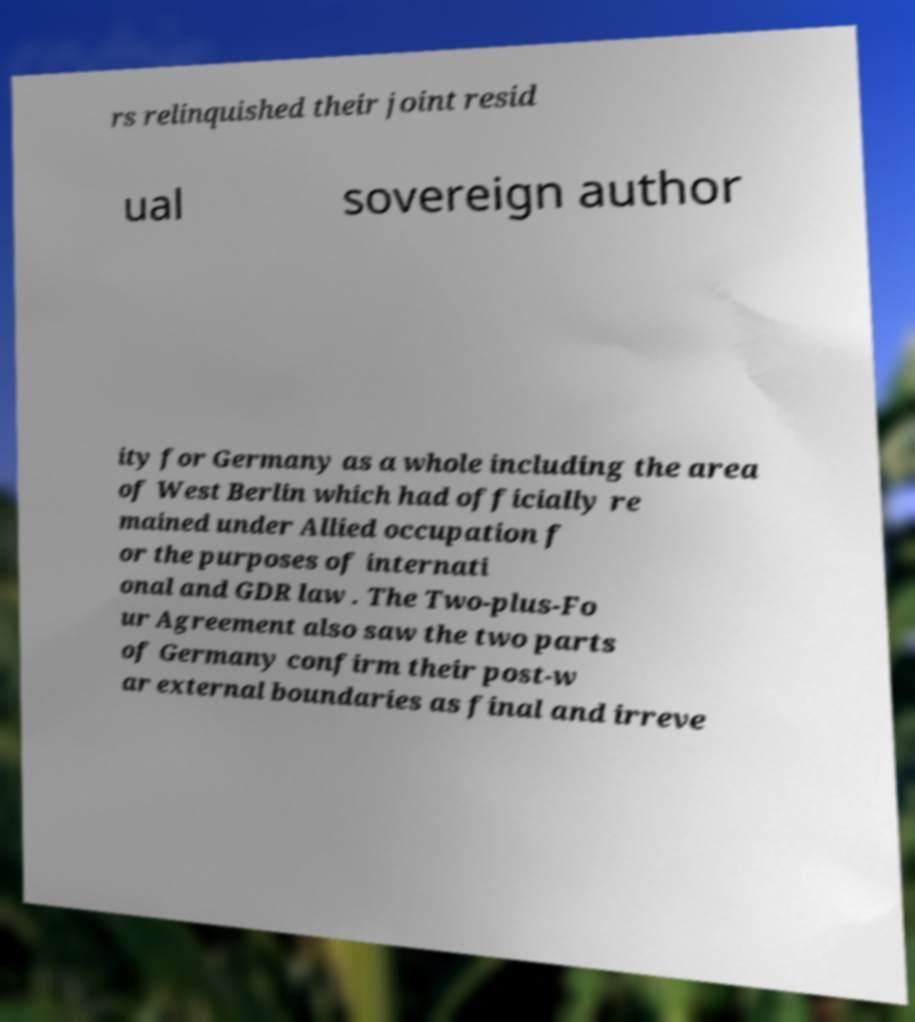There's text embedded in this image that I need extracted. Can you transcribe it verbatim? rs relinquished their joint resid ual sovereign author ity for Germany as a whole including the area of West Berlin which had officially re mained under Allied occupation f or the purposes of internati onal and GDR law . The Two-plus-Fo ur Agreement also saw the two parts of Germany confirm their post-w ar external boundaries as final and irreve 